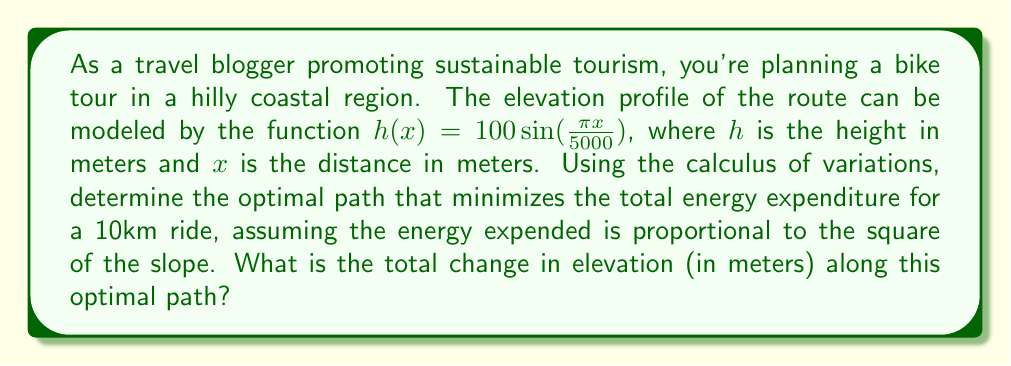Can you solve this math problem? To solve this problem, we'll use the Euler-Lagrange equation from the calculus of variations. The steps are as follows:

1) The functional to be minimized is:

   $$J[y] = \int_0^{10000} \left(\frac{dy}{dx}\right)^2 dx$$

   Where $y(x)$ represents the elevation at each point $x$ along the path.

2) The Euler-Lagrange equation is:

   $$\frac{\partial L}{\partial y} - \frac{d}{dx}\left(\frac{\partial L}{\partial y'}\right) = 0$$

   Where $L = (y')^2$ in this case.

3) Applying the Euler-Lagrange equation:

   $$0 - \frac{d}{dx}(2y') = 0$$
   $$\frac{d}{dx}(y') = 0$$

4) This implies that $y'$ is constant. Let's call this constant $C$:

   $$y' = C$$

5) Integrating both sides:

   $$y = Cx + D$$

   Where $D$ is another constant.

6) To determine $C$ and $D$, we use the boundary conditions:

   At $x = 0$, $y(0) = 100 \sin(0) = 0$
   At $x = 10000$, $y(10000) = 100 \sin(\frac{\pi 10000}{5000}) = 0$

7) Applying these conditions:

   $0 = D$
   $0 = 10000C + D$

8) Solving these equations:

   $D = 0$
   $C = 0$

9) Therefore, the optimal path is a straight line at $y = 0$.

10) The total change in elevation is the absolute difference between the start and end elevations, which is:

    $|0 - 0| = 0$ meters
Answer: 0 meters 